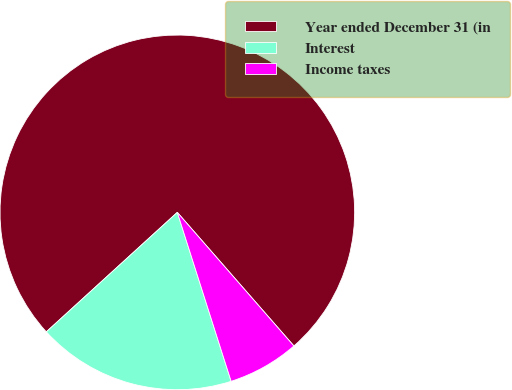Convert chart. <chart><loc_0><loc_0><loc_500><loc_500><pie_chart><fcel>Year ended December 31 (in<fcel>Interest<fcel>Income taxes<nl><fcel>75.35%<fcel>18.14%<fcel>6.51%<nl></chart> 